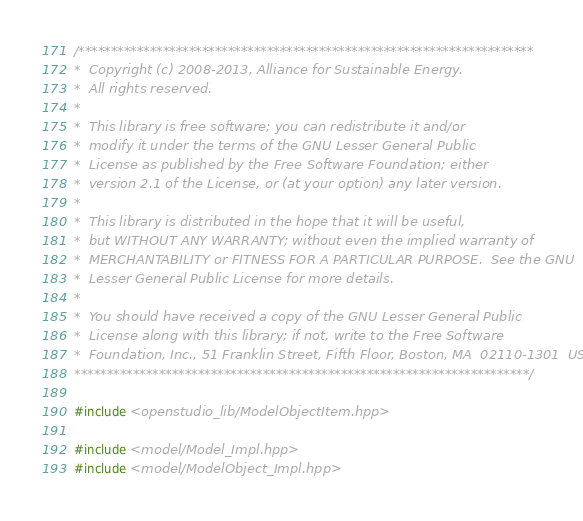Convert code to text. <code><loc_0><loc_0><loc_500><loc_500><_C++_>/**********************************************************************
*  Copyright (c) 2008-2013, Alliance for Sustainable Energy.
*  All rights reserved.
*
*  This library is free software; you can redistribute it and/or
*  modify it under the terms of the GNU Lesser General Public
*  License as published by the Free Software Foundation; either
*  version 2.1 of the License, or (at your option) any later version.
*
*  This library is distributed in the hope that it will be useful,
*  but WITHOUT ANY WARRANTY; without even the implied warranty of
*  MERCHANTABILITY or FITNESS FOR A PARTICULAR PURPOSE.  See the GNU
*  Lesser General Public License for more details.
*
*  You should have received a copy of the GNU Lesser General Public
*  License along with this library; if not, write to the Free Software
*  Foundation, Inc., 51 Franklin Street, Fifth Floor, Boston, MA  02110-1301  USA
**********************************************************************/

#include <openstudio_lib/ModelObjectItem.hpp>

#include <model/Model_Impl.hpp>
#include <model/ModelObject_Impl.hpp></code> 